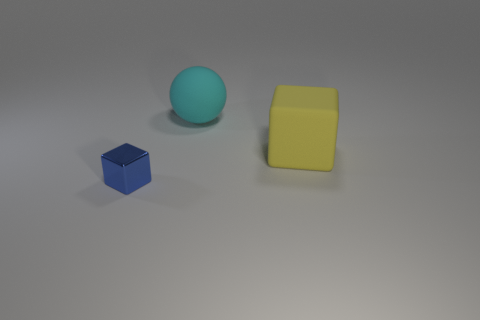Add 3 rubber things. How many objects exist? 6 Subtract all balls. How many objects are left? 2 Subtract all big cyan balls. Subtract all metal objects. How many objects are left? 1 Add 2 tiny blue objects. How many tiny blue objects are left? 3 Add 1 small gray shiny cylinders. How many small gray shiny cylinders exist? 1 Subtract 0 yellow spheres. How many objects are left? 3 